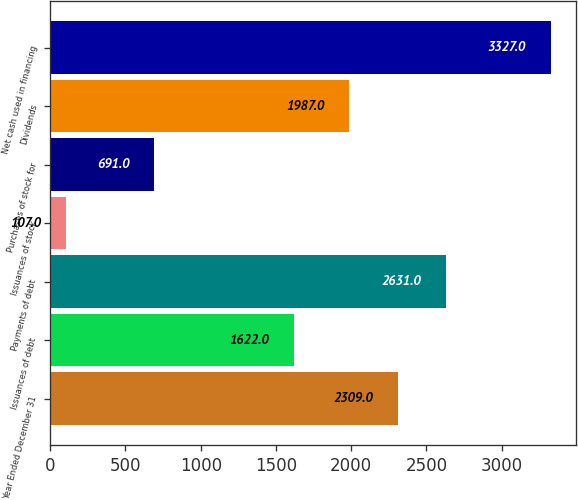Convert chart to OTSL. <chart><loc_0><loc_0><loc_500><loc_500><bar_chart><fcel>Year Ended December 31<fcel>Issuances of debt<fcel>Payments of debt<fcel>Issuances of stock<fcel>Purchases of stock for<fcel>Dividends<fcel>Net cash used in financing<nl><fcel>2309<fcel>1622<fcel>2631<fcel>107<fcel>691<fcel>1987<fcel>3327<nl></chart> 